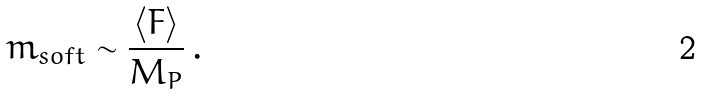<formula> <loc_0><loc_0><loc_500><loc_500>m _ { s o f t } \sim \frac { \langle F \rangle } { M _ { P } } \, .</formula> 